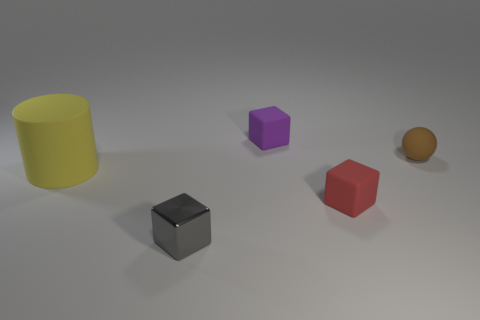Add 3 metal things. How many objects exist? 8 Subtract all spheres. How many objects are left? 4 Subtract all tiny brown rubber objects. Subtract all shiny objects. How many objects are left? 3 Add 4 red rubber blocks. How many red rubber blocks are left? 5 Add 2 metallic objects. How many metallic objects exist? 3 Subtract 0 red spheres. How many objects are left? 5 